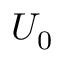Convert formula to latex. <formula><loc_0><loc_0><loc_500><loc_500>U _ { 0 }</formula> 